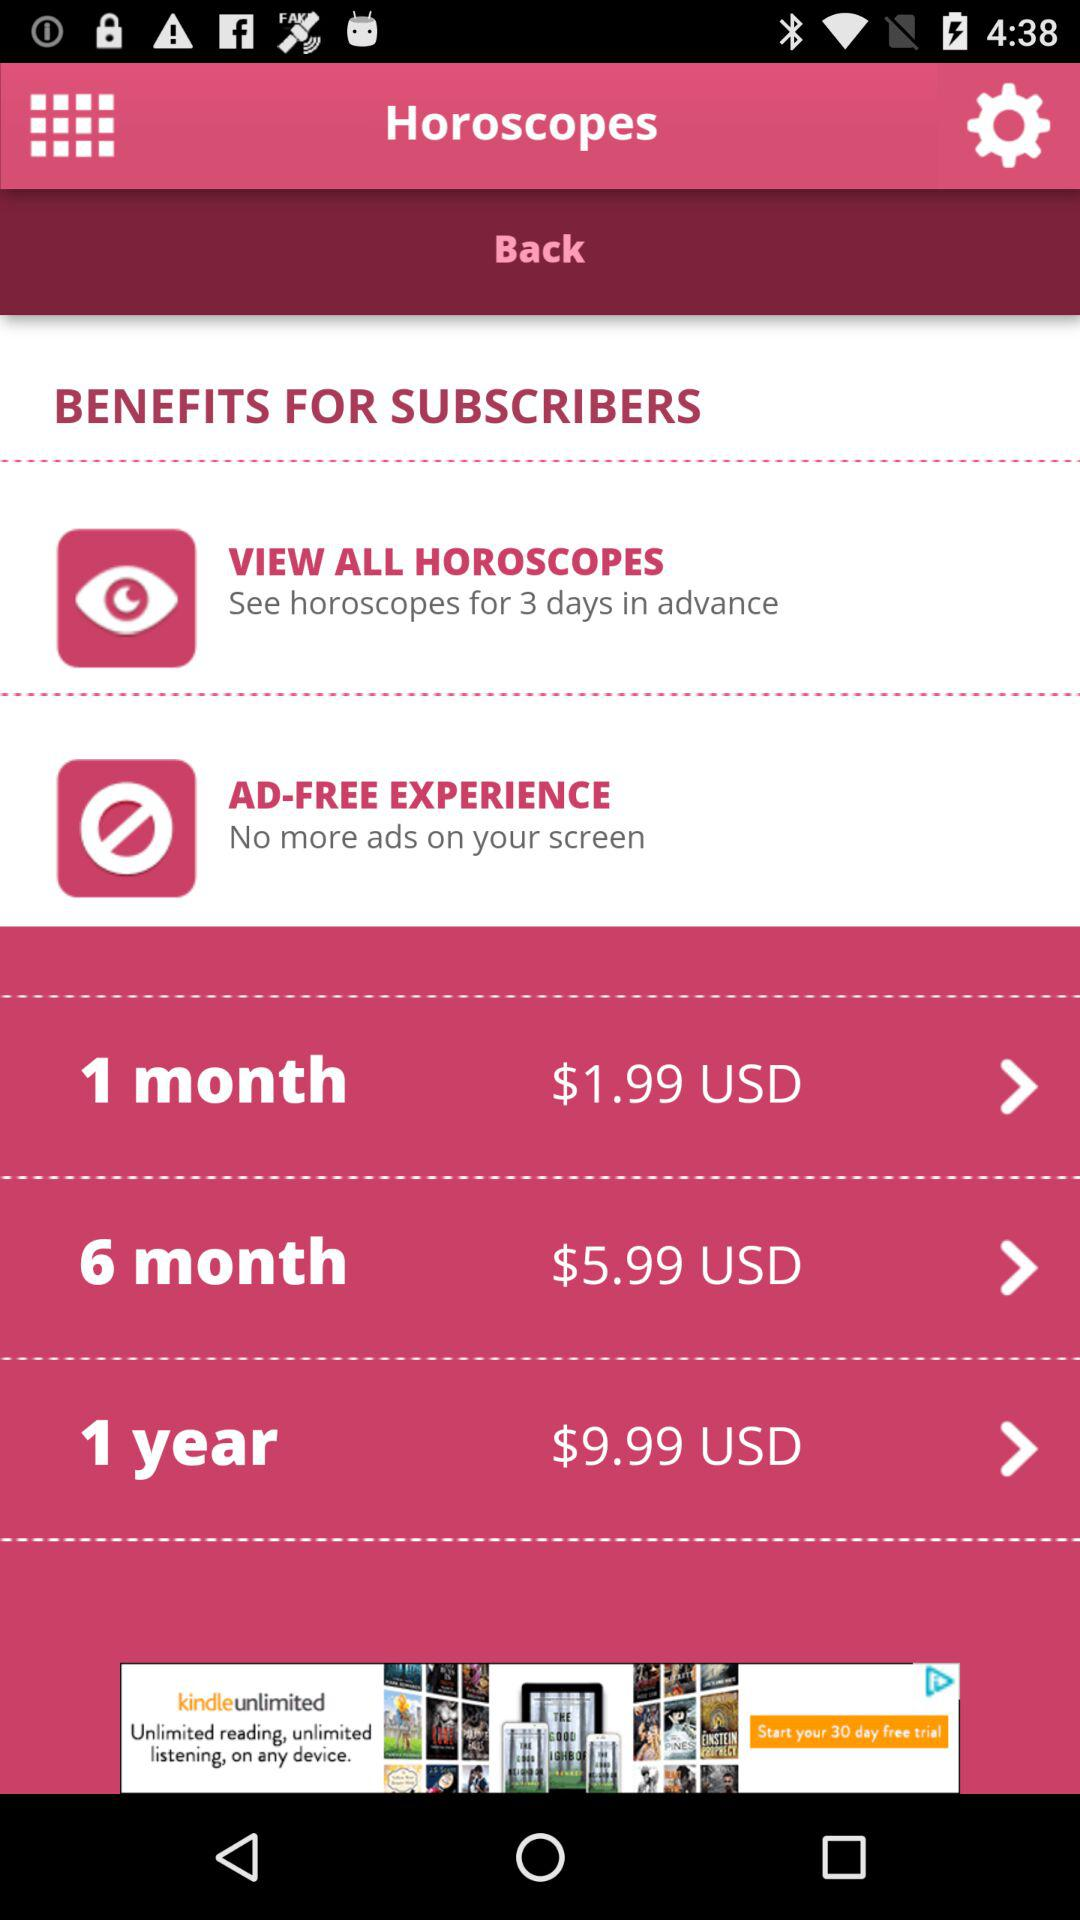What is the price of the 1 month plan? The price is $1.99 USD. 